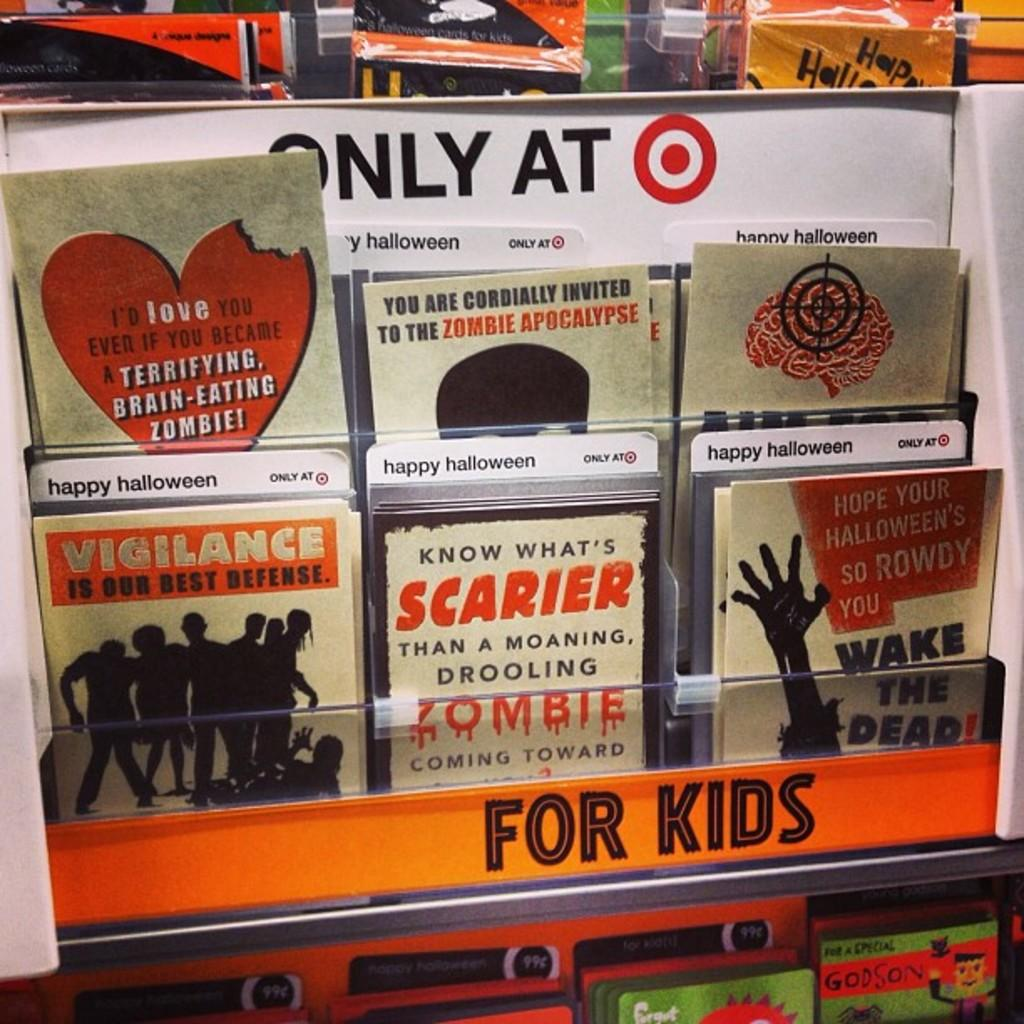<image>
Render a clear and concise summary of the photo. Cards about zombies are on a display at a Target store. 